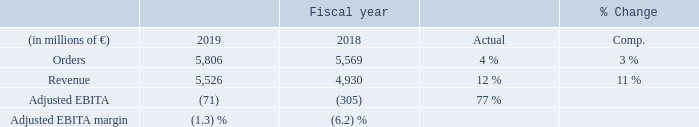Supported by a recovery in commodity-related markets, orders and revenue showed broad-based growth year-over-year with strongest increases in the mechanical drives business. Overall, Portfolio Companies businesses made good progress in achieving their targets. Adjusted EBITA improved in all fully consolidated units and turned positive in total, mainly driven by the large drives applications business.
The result from equity investments in total also improved slightly, though it was negative in both periods under review. Severance charges decreased to € 14 million, from € 86 million in fiscal 2018. Portfolio Companies’ order backlog was € 5 billion at the end of the fiscal year, of which € 3 billion are expected to be converted into revenue in fiscal 2020. Regarding Portfolio Companies’ at-equity investments, volatile results are expected in coming quarters.
Markets for Portfolio Companies are generally impacted by rising uncertainties regarding geopolitical and economic developments, which weaken investment sentiment. Although the broad range of businesses are operating in diverse markets, overall, moderate growth is expected in the coming years for the main markets served by the Portfolio Companies.
Beginning with fiscal 2020, the equity investments Ethos Energy Group Limited and Voith Hydro Holding GmbH & Co. KG, the subsea business, and the majority of the process solutions business will be transferred to the Operating Company Gas and Power. If this organizational structure had already existed in fiscal 2019, Portfolio Companies would have posted orders of € 4.746 billion, revenue of € 4.558 billion and Adjusted EBITA of €(115) million.
Mitsubishi-Hitachi Metals Machinery (MHMM) and Siemens AG reached an agreement in September 2019, that MHMM will acquire Siemens’ stake in Primetals Technologies. Closing of the transaction is subject to customary conditions and is expected by the beginning of calendar 2020.
What was the reason for the increase in the Adjusted EBITDA? Adjusted ebita improved in all fully consolidated units and turned positive in total, mainly driven by the large drives applications business. How have the markets for Portfolio Companies been impacted? Markets for portfolio companies are generally impacted by rising uncertainties regarding geopolitical and economic developments, which weaken investment sentiment. If the new organizational structure had already existed in fiscal 2019, Smart Infrastructure would have posted what revenue in 2019?  4.558 billion. What was the average orders for 2019 and 2018?
Answer scale should be: million. (5,806 + 5,569) / 2
Answer: 5687.5. What is the increase / (decrease) in revenue from 2018 to 2019?
Answer scale should be: million. 5,526 - 4,930
Answer: 596. What is the increase / (decrease) in the Adjusted EBITDA margin from 2018 to 2019?
Answer scale should be: percent. (1.3%) - (6.2%)
Answer: -4.9. 